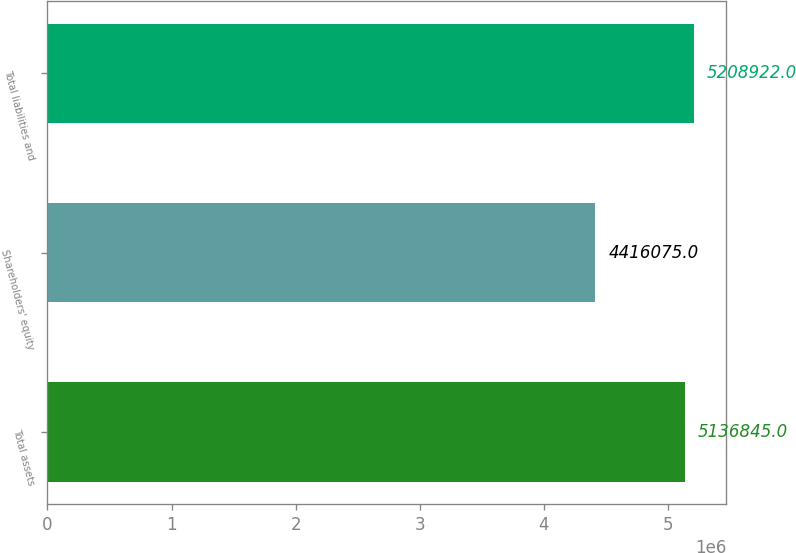Convert chart to OTSL. <chart><loc_0><loc_0><loc_500><loc_500><bar_chart><fcel>Total assets<fcel>Shareholders' equity<fcel>Total liabilities and<nl><fcel>5.13684e+06<fcel>4.41608e+06<fcel>5.20892e+06<nl></chart> 